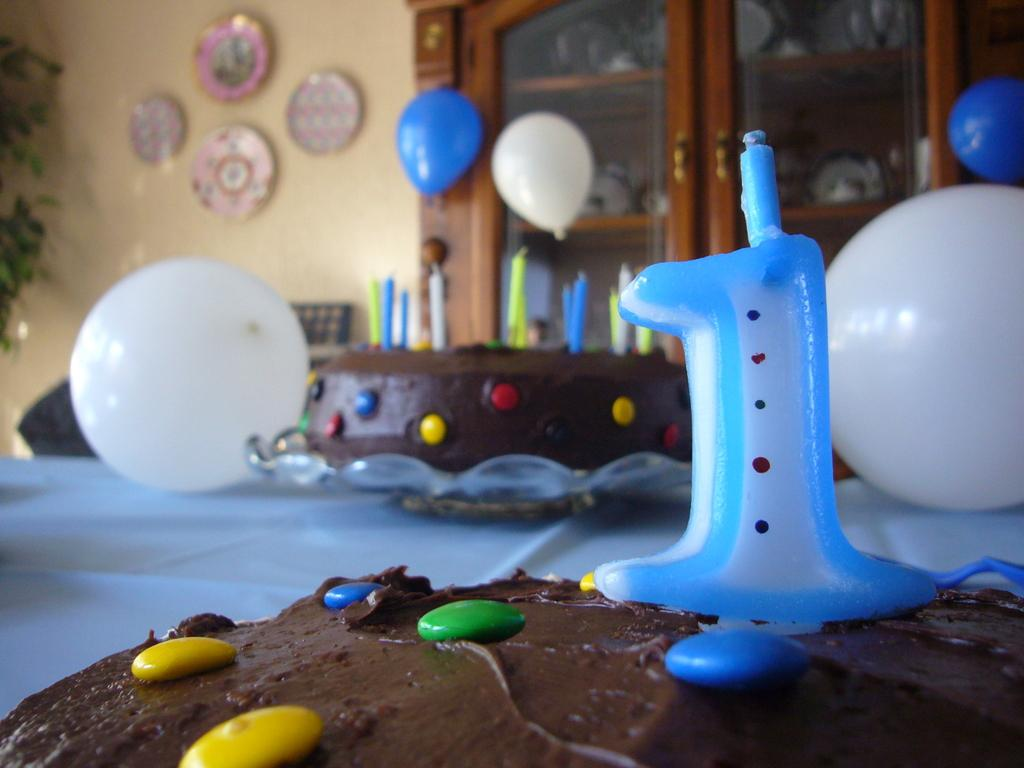What is on the table in the image? There are two cakes on a table in the image. What is special about the cakes? The cakes have candles on them. What else can be seen in the image besides the cakes? There are balloons and wall hangings in the image. What type of furniture is present in the image? There is a wooden cupboard in the image. What answer can be found on the cakes in the image? There is no answer written on the cakes in the image; they are decorated with candles. 